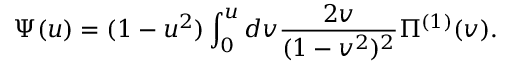<formula> <loc_0><loc_0><loc_500><loc_500>\Psi ( u ) = ( 1 - u ^ { 2 } ) \int _ { 0 } ^ { u } d v \frac { 2 v } { ( 1 - v ^ { 2 } ) ^ { 2 } } \Pi ^ { ( 1 ) } ( v ) .</formula> 